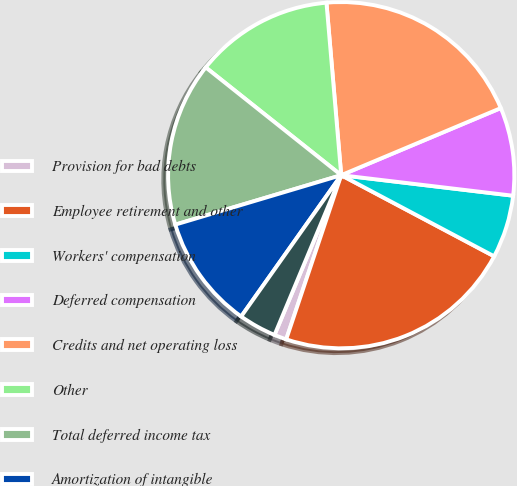Convert chart. <chart><loc_0><loc_0><loc_500><loc_500><pie_chart><fcel>Provision for bad debts<fcel>Employee retirement and other<fcel>Workers' compensation<fcel>Deferred compensation<fcel>Credits and net operating loss<fcel>Other<fcel>Total deferred income tax<fcel>Amortization of intangible<fcel>Property and equipment basis<nl><fcel>1.15%<fcel>22.39%<fcel>5.87%<fcel>8.23%<fcel>20.03%<fcel>12.95%<fcel>15.31%<fcel>10.59%<fcel>3.51%<nl></chart> 